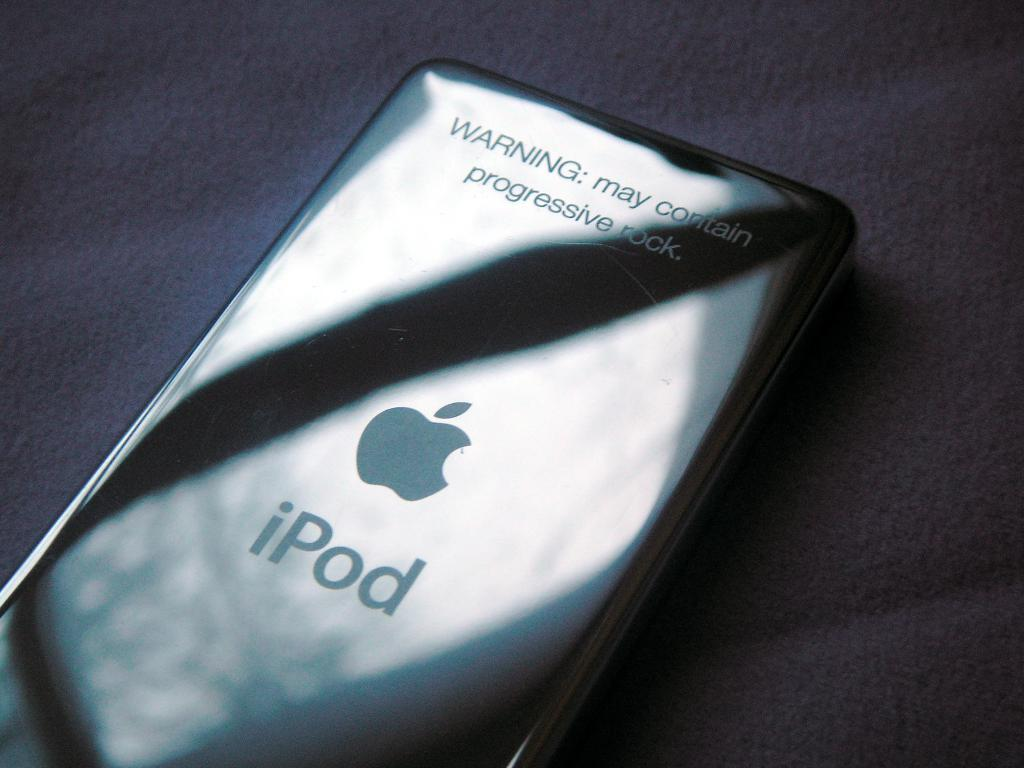<image>
Provide a brief description of the given image. A facedown iPod has a Warning about progressive rock on the top. 